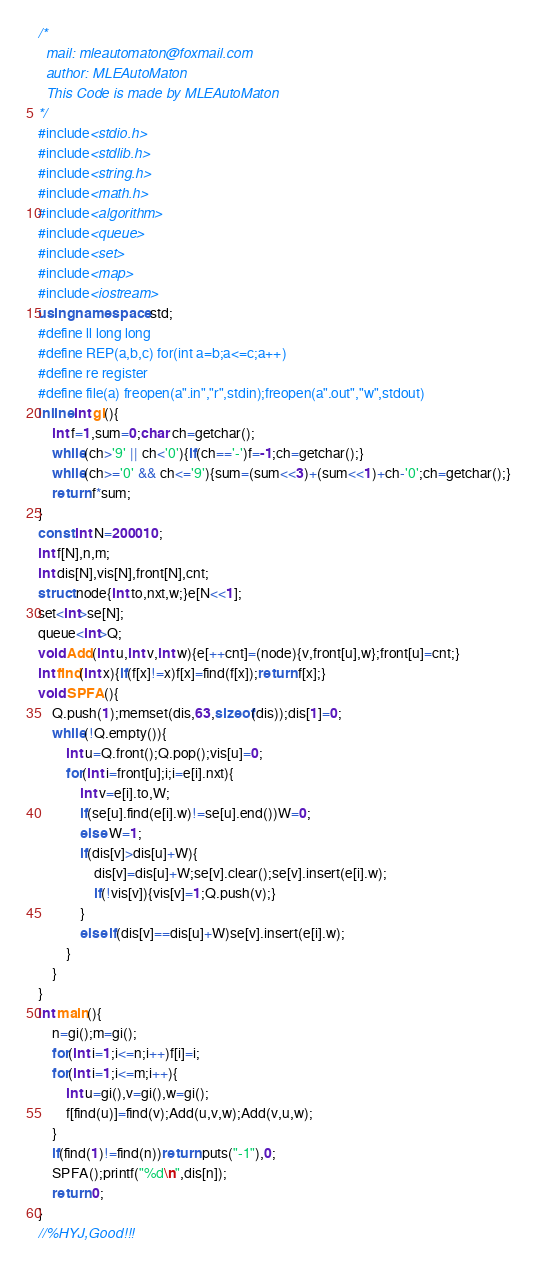Convert code to text. <code><loc_0><loc_0><loc_500><loc_500><_C++_>/*
  mail: mleautomaton@foxmail.com
  author: MLEAutoMaton
  This Code is made by MLEAutoMaton
*/
#include<stdio.h>
#include<stdlib.h>
#include<string.h>
#include<math.h>
#include<algorithm>
#include<queue>
#include<set>
#include<map>
#include<iostream>
using namespace std;
#define ll long long
#define REP(a,b,c) for(int a=b;a<=c;a++)
#define re register
#define file(a) freopen(a".in","r",stdin);freopen(a".out","w",stdout)
inline int gi(){
	int f=1,sum=0;char ch=getchar();
	while(ch>'9' || ch<'0'){if(ch=='-')f=-1;ch=getchar();}
	while(ch>='0' && ch<='9'){sum=(sum<<3)+(sum<<1)+ch-'0';ch=getchar();}
	return f*sum;
}
const int N=200010;
int f[N],n,m;
int dis[N],vis[N],front[N],cnt;
struct node{int to,nxt,w;}e[N<<1];
set<int>se[N];
queue<int>Q;
void Add(int u,int v,int w){e[++cnt]=(node){v,front[u],w};front[u]=cnt;}
int find(int x){if(f[x]!=x)f[x]=find(f[x]);return f[x];}
void SPFA(){
	Q.push(1);memset(dis,63,sizeof(dis));dis[1]=0;
	while(!Q.empty()){
		int u=Q.front();Q.pop();vis[u]=0;
		for(int i=front[u];i;i=e[i].nxt){
			int v=e[i].to,W;
			if(se[u].find(e[i].w)!=se[u].end())W=0;
			else W=1;
			if(dis[v]>dis[u]+W){
				dis[v]=dis[u]+W;se[v].clear();se[v].insert(e[i].w);
				if(!vis[v]){vis[v]=1;Q.push(v);}
			}
			else if(dis[v]==dis[u]+W)se[v].insert(e[i].w);
		}
	}
}
int main(){
	n=gi();m=gi();
	for(int i=1;i<=n;i++)f[i]=i;
	for(int i=1;i<=m;i++){
		int u=gi(),v=gi(),w=gi();
		f[find(u)]=find(v);Add(u,v,w);Add(v,u,w);
	}
	if(find(1)!=find(n))return puts("-1"),0;
	SPFA();printf("%d\n",dis[n]);
	return 0;
}
//%HYJ,Good!!!
</code> 